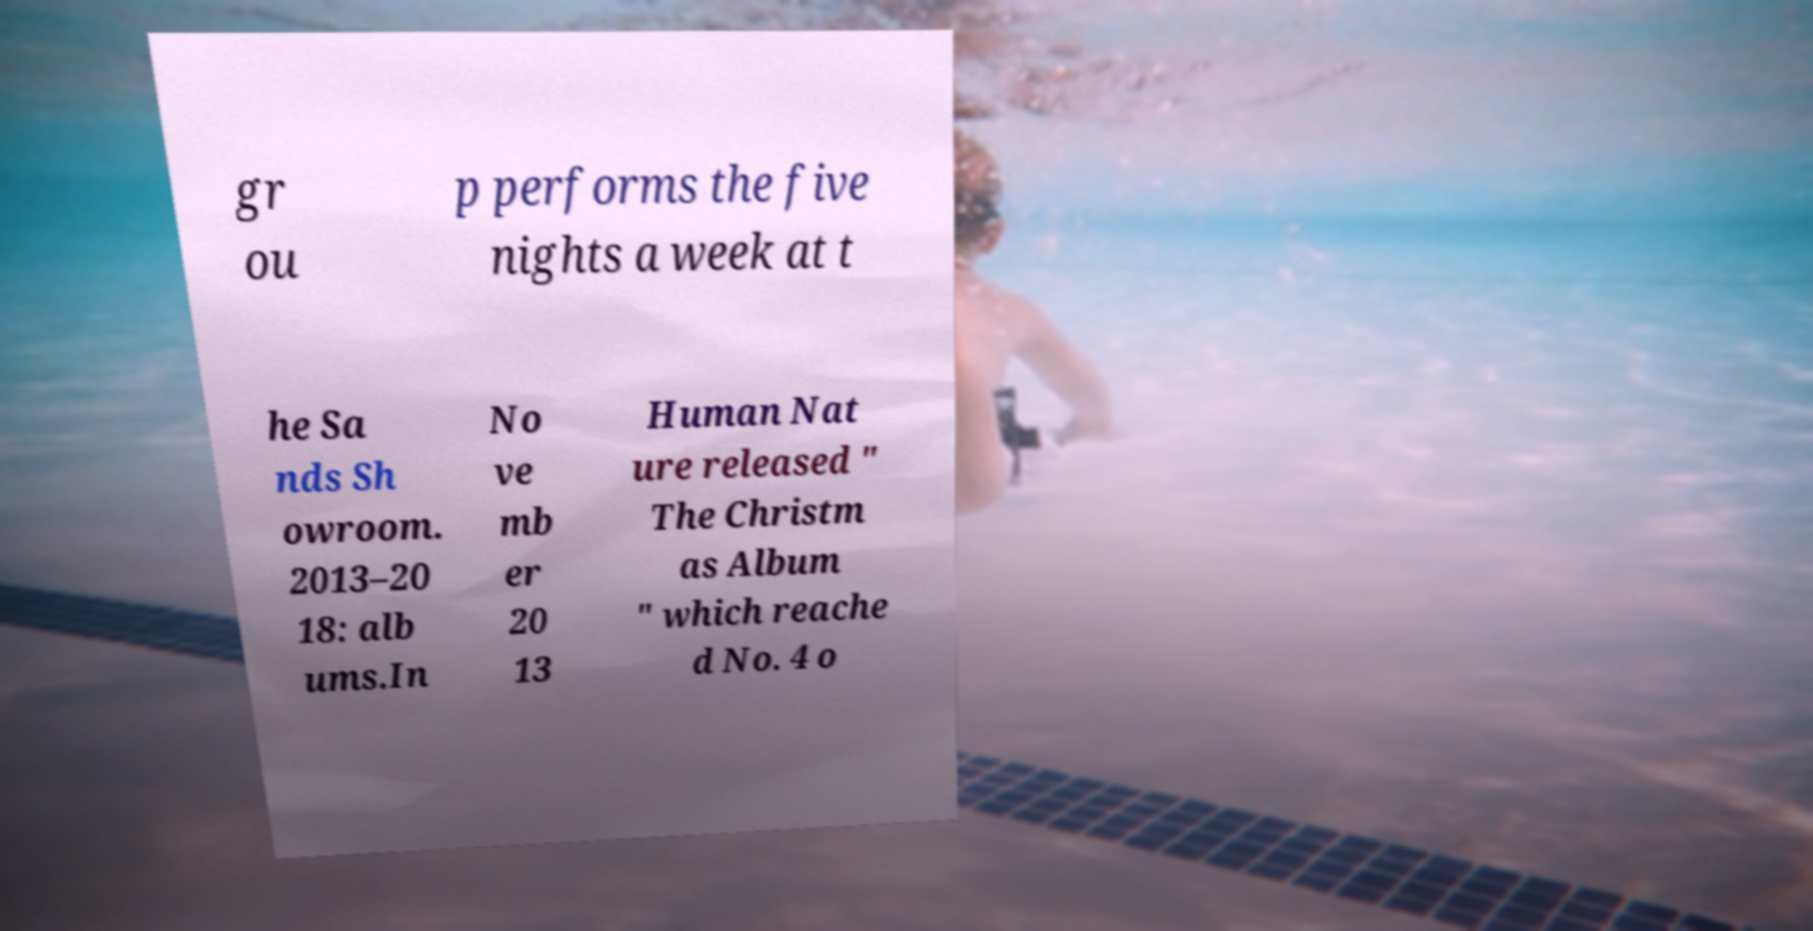Can you read and provide the text displayed in the image?This photo seems to have some interesting text. Can you extract and type it out for me? gr ou p performs the five nights a week at t he Sa nds Sh owroom. 2013–20 18: alb ums.In No ve mb er 20 13 Human Nat ure released " The Christm as Album " which reache d No. 4 o 